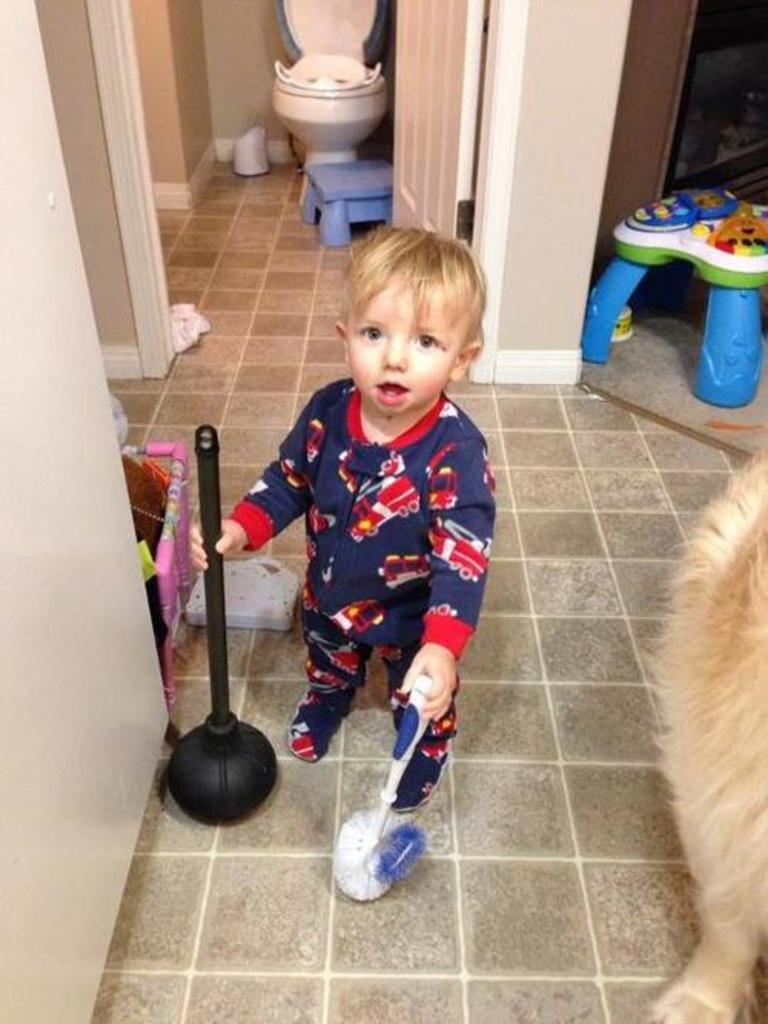What is the main subject of the image? There is a child in the image. What is the child doing in the image? The child is standing on the ground and holding a brush. Are there any animals in the image? Yes, there is a dog in the image. What type of structure can be seen in the background? There is a wall and a door in the image. What else can be seen in the image? There are stools and some objects in the image. What type of noise is the child making while holding the brush in the image? There is no indication of any noise being made by the child in the image. Can you tell me how the child's father is interacting with the child in the image? There is no mention of the child's father in the image, so it cannot be determined how they might be interacting. 